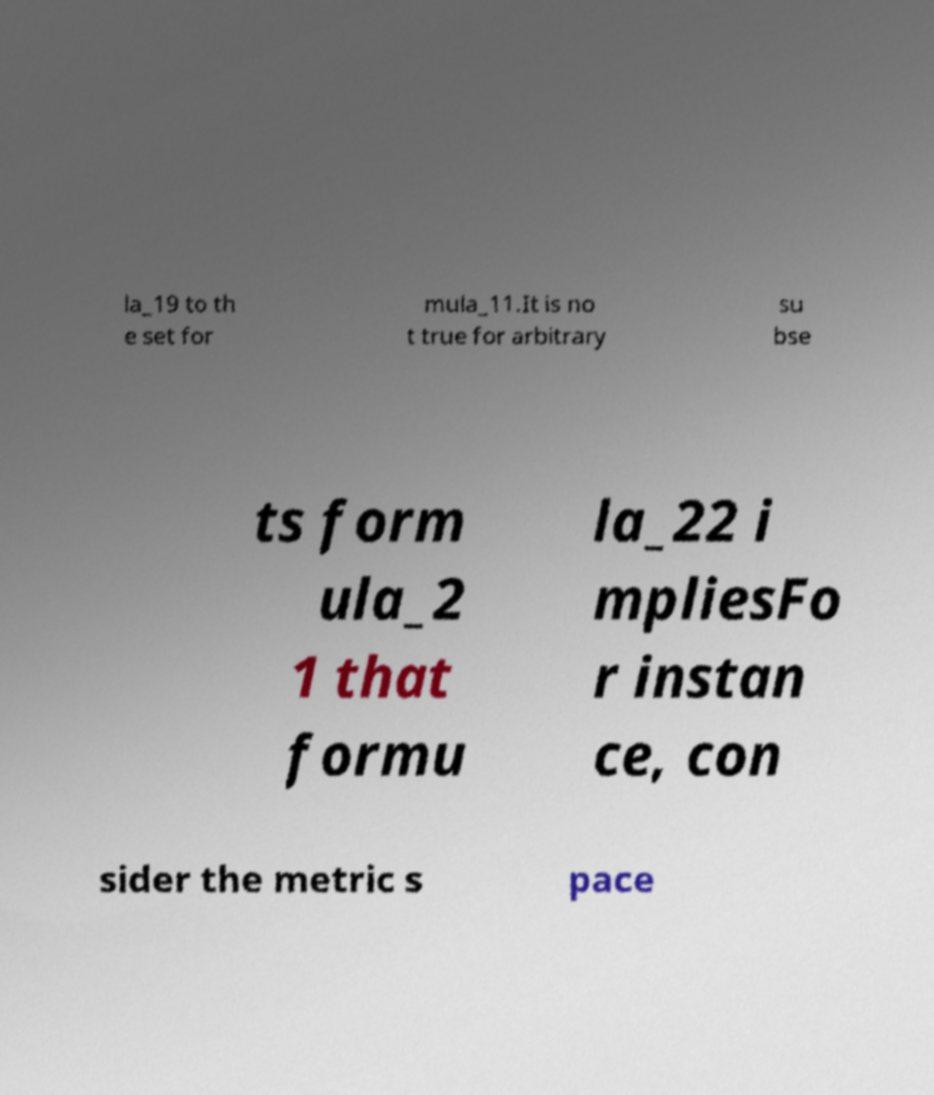Can you accurately transcribe the text from the provided image for me? la_19 to th e set for mula_11.It is no t true for arbitrary su bse ts form ula_2 1 that formu la_22 i mpliesFo r instan ce, con sider the metric s pace 